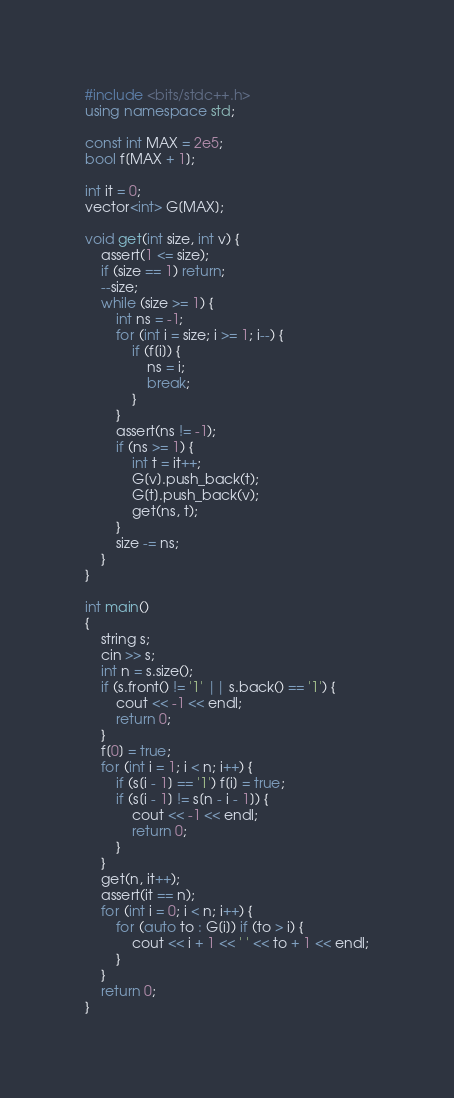<code> <loc_0><loc_0><loc_500><loc_500><_C++_>#include <bits/stdc++.h>
using namespace std;

const int MAX = 2e5;
bool f[MAX + 1];

int it = 0;
vector<int> G[MAX];

void get(int size, int v) {
	assert(1 <= size);
	if (size == 1) return;
	--size;
	while (size >= 1) {
		int ns = -1;
		for (int i = size; i >= 1; i--) {
			if (f[i]) {
				ns = i;
				break;
			}
		}
		assert(ns != -1);
		if (ns >= 1) {
			int t = it++;
			G[v].push_back(t);
			G[t].push_back(v);
			get(ns, t);
		}
		size -= ns;
	}
}

int main()
{
	string s;
	cin >> s;
	int n = s.size();
	if (s.front() != '1' || s.back() == '1') {
		cout << -1 << endl;
		return 0;
	}
	f[0] = true;
	for (int i = 1; i < n; i++) {
		if (s[i - 1] == '1') f[i] = true;
		if (s[i - 1] != s[n - i - 1]) {
			cout << -1 << endl;
			return 0;
		}
	}
	get(n, it++);
	assert(it == n);
	for (int i = 0; i < n; i++) {
		for (auto to : G[i]) if (to > i) {
			cout << i + 1 << ' ' << to + 1 << endl;
		}
	}
	return 0;
}
</code> 